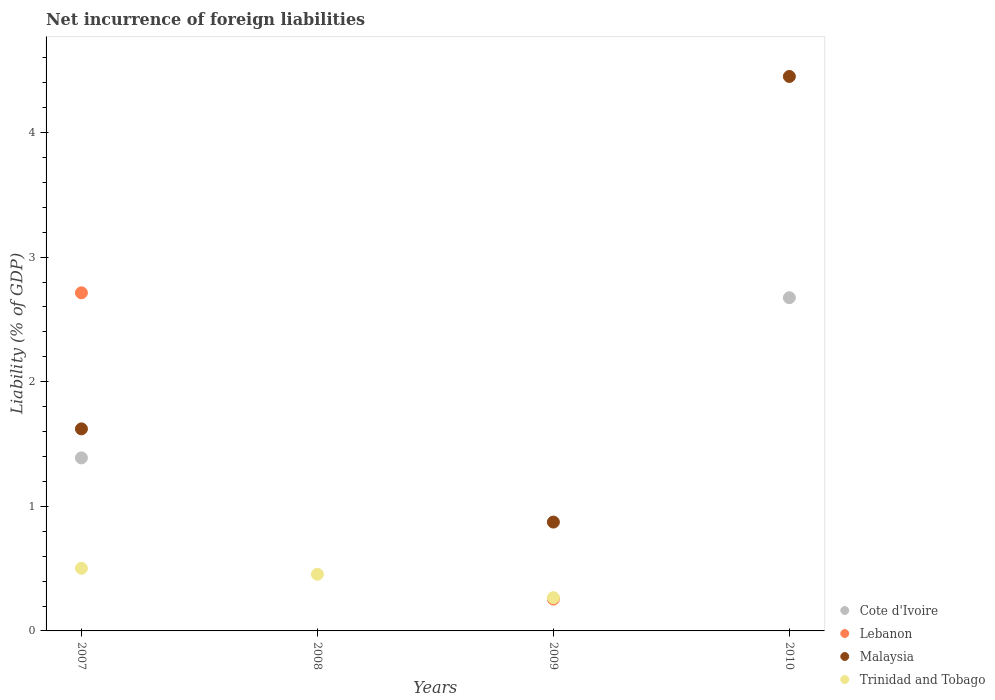How many different coloured dotlines are there?
Keep it short and to the point. 4. What is the net incurrence of foreign liabilities in Malaysia in 2008?
Offer a very short reply. 0. Across all years, what is the maximum net incurrence of foreign liabilities in Lebanon?
Offer a very short reply. 2.71. Across all years, what is the minimum net incurrence of foreign liabilities in Cote d'Ivoire?
Offer a terse response. 0. In which year was the net incurrence of foreign liabilities in Cote d'Ivoire maximum?
Your response must be concise. 2010. What is the total net incurrence of foreign liabilities in Trinidad and Tobago in the graph?
Your response must be concise. 1.22. What is the difference between the net incurrence of foreign liabilities in Cote d'Ivoire in 2007 and that in 2010?
Make the answer very short. -1.29. What is the difference between the net incurrence of foreign liabilities in Lebanon in 2010 and the net incurrence of foreign liabilities in Trinidad and Tobago in 2007?
Your answer should be compact. -0.5. What is the average net incurrence of foreign liabilities in Lebanon per year?
Provide a succinct answer. 0.74. In the year 2010, what is the difference between the net incurrence of foreign liabilities in Cote d'Ivoire and net incurrence of foreign liabilities in Malaysia?
Provide a short and direct response. -1.78. What is the ratio of the net incurrence of foreign liabilities in Lebanon in 2007 to that in 2009?
Your answer should be very brief. 10.61. Is the net incurrence of foreign liabilities in Trinidad and Tobago in 2007 less than that in 2009?
Provide a short and direct response. No. What is the difference between the highest and the second highest net incurrence of foreign liabilities in Trinidad and Tobago?
Keep it short and to the point. 0.05. What is the difference between the highest and the lowest net incurrence of foreign liabilities in Lebanon?
Your answer should be very brief. 2.71. Is it the case that in every year, the sum of the net incurrence of foreign liabilities in Lebanon and net incurrence of foreign liabilities in Malaysia  is greater than the net incurrence of foreign liabilities in Trinidad and Tobago?
Your answer should be very brief. No. What is the difference between two consecutive major ticks on the Y-axis?
Provide a succinct answer. 1. Does the graph contain grids?
Offer a very short reply. No. How many legend labels are there?
Give a very brief answer. 4. What is the title of the graph?
Make the answer very short. Net incurrence of foreign liabilities. What is the label or title of the X-axis?
Provide a succinct answer. Years. What is the label or title of the Y-axis?
Provide a succinct answer. Liability (% of GDP). What is the Liability (% of GDP) in Cote d'Ivoire in 2007?
Keep it short and to the point. 1.39. What is the Liability (% of GDP) in Lebanon in 2007?
Make the answer very short. 2.71. What is the Liability (% of GDP) of Malaysia in 2007?
Provide a succinct answer. 1.62. What is the Liability (% of GDP) of Trinidad and Tobago in 2007?
Give a very brief answer. 0.5. What is the Liability (% of GDP) of Cote d'Ivoire in 2008?
Provide a short and direct response. 0. What is the Liability (% of GDP) of Lebanon in 2008?
Your answer should be compact. 0. What is the Liability (% of GDP) of Trinidad and Tobago in 2008?
Your answer should be compact. 0.45. What is the Liability (% of GDP) in Cote d'Ivoire in 2009?
Give a very brief answer. 0. What is the Liability (% of GDP) of Lebanon in 2009?
Offer a very short reply. 0.26. What is the Liability (% of GDP) of Malaysia in 2009?
Your response must be concise. 0.87. What is the Liability (% of GDP) of Trinidad and Tobago in 2009?
Your response must be concise. 0.27. What is the Liability (% of GDP) of Cote d'Ivoire in 2010?
Offer a terse response. 2.67. What is the Liability (% of GDP) of Malaysia in 2010?
Give a very brief answer. 4.45. What is the Liability (% of GDP) of Trinidad and Tobago in 2010?
Make the answer very short. 0. Across all years, what is the maximum Liability (% of GDP) in Cote d'Ivoire?
Provide a short and direct response. 2.67. Across all years, what is the maximum Liability (% of GDP) of Lebanon?
Provide a succinct answer. 2.71. Across all years, what is the maximum Liability (% of GDP) of Malaysia?
Your response must be concise. 4.45. Across all years, what is the maximum Liability (% of GDP) in Trinidad and Tobago?
Your response must be concise. 0.5. Across all years, what is the minimum Liability (% of GDP) in Cote d'Ivoire?
Your answer should be very brief. 0. Across all years, what is the minimum Liability (% of GDP) of Trinidad and Tobago?
Your answer should be very brief. 0. What is the total Liability (% of GDP) in Cote d'Ivoire in the graph?
Offer a very short reply. 4.06. What is the total Liability (% of GDP) in Lebanon in the graph?
Keep it short and to the point. 2.97. What is the total Liability (% of GDP) of Malaysia in the graph?
Ensure brevity in your answer.  6.94. What is the total Liability (% of GDP) in Trinidad and Tobago in the graph?
Your response must be concise. 1.22. What is the difference between the Liability (% of GDP) in Trinidad and Tobago in 2007 and that in 2008?
Provide a short and direct response. 0.05. What is the difference between the Liability (% of GDP) of Lebanon in 2007 and that in 2009?
Ensure brevity in your answer.  2.46. What is the difference between the Liability (% of GDP) in Malaysia in 2007 and that in 2009?
Keep it short and to the point. 0.75. What is the difference between the Liability (% of GDP) in Trinidad and Tobago in 2007 and that in 2009?
Offer a terse response. 0.24. What is the difference between the Liability (% of GDP) in Cote d'Ivoire in 2007 and that in 2010?
Keep it short and to the point. -1.29. What is the difference between the Liability (% of GDP) in Malaysia in 2007 and that in 2010?
Your answer should be very brief. -2.83. What is the difference between the Liability (% of GDP) in Trinidad and Tobago in 2008 and that in 2009?
Give a very brief answer. 0.19. What is the difference between the Liability (% of GDP) in Malaysia in 2009 and that in 2010?
Offer a terse response. -3.58. What is the difference between the Liability (% of GDP) in Cote d'Ivoire in 2007 and the Liability (% of GDP) in Trinidad and Tobago in 2008?
Keep it short and to the point. 0.93. What is the difference between the Liability (% of GDP) in Lebanon in 2007 and the Liability (% of GDP) in Trinidad and Tobago in 2008?
Keep it short and to the point. 2.26. What is the difference between the Liability (% of GDP) of Malaysia in 2007 and the Liability (% of GDP) of Trinidad and Tobago in 2008?
Your response must be concise. 1.17. What is the difference between the Liability (% of GDP) of Cote d'Ivoire in 2007 and the Liability (% of GDP) of Lebanon in 2009?
Your answer should be very brief. 1.13. What is the difference between the Liability (% of GDP) of Cote d'Ivoire in 2007 and the Liability (% of GDP) of Malaysia in 2009?
Your response must be concise. 0.52. What is the difference between the Liability (% of GDP) of Cote d'Ivoire in 2007 and the Liability (% of GDP) of Trinidad and Tobago in 2009?
Provide a short and direct response. 1.12. What is the difference between the Liability (% of GDP) of Lebanon in 2007 and the Liability (% of GDP) of Malaysia in 2009?
Your answer should be compact. 1.84. What is the difference between the Liability (% of GDP) in Lebanon in 2007 and the Liability (% of GDP) in Trinidad and Tobago in 2009?
Ensure brevity in your answer.  2.45. What is the difference between the Liability (% of GDP) in Malaysia in 2007 and the Liability (% of GDP) in Trinidad and Tobago in 2009?
Your answer should be very brief. 1.35. What is the difference between the Liability (% of GDP) of Cote d'Ivoire in 2007 and the Liability (% of GDP) of Malaysia in 2010?
Offer a very short reply. -3.06. What is the difference between the Liability (% of GDP) of Lebanon in 2007 and the Liability (% of GDP) of Malaysia in 2010?
Offer a terse response. -1.74. What is the difference between the Liability (% of GDP) in Lebanon in 2009 and the Liability (% of GDP) in Malaysia in 2010?
Offer a terse response. -4.19. What is the average Liability (% of GDP) of Cote d'Ivoire per year?
Your response must be concise. 1.02. What is the average Liability (% of GDP) in Lebanon per year?
Keep it short and to the point. 0.74. What is the average Liability (% of GDP) of Malaysia per year?
Keep it short and to the point. 1.74. What is the average Liability (% of GDP) in Trinidad and Tobago per year?
Ensure brevity in your answer.  0.31. In the year 2007, what is the difference between the Liability (% of GDP) in Cote d'Ivoire and Liability (% of GDP) in Lebanon?
Offer a very short reply. -1.32. In the year 2007, what is the difference between the Liability (% of GDP) in Cote d'Ivoire and Liability (% of GDP) in Malaysia?
Ensure brevity in your answer.  -0.23. In the year 2007, what is the difference between the Liability (% of GDP) in Cote d'Ivoire and Liability (% of GDP) in Trinidad and Tobago?
Give a very brief answer. 0.89. In the year 2007, what is the difference between the Liability (% of GDP) of Lebanon and Liability (% of GDP) of Malaysia?
Provide a short and direct response. 1.09. In the year 2007, what is the difference between the Liability (% of GDP) in Lebanon and Liability (% of GDP) in Trinidad and Tobago?
Your answer should be compact. 2.21. In the year 2007, what is the difference between the Liability (% of GDP) in Malaysia and Liability (% of GDP) in Trinidad and Tobago?
Ensure brevity in your answer.  1.12. In the year 2009, what is the difference between the Liability (% of GDP) of Lebanon and Liability (% of GDP) of Malaysia?
Ensure brevity in your answer.  -0.62. In the year 2009, what is the difference between the Liability (% of GDP) in Lebanon and Liability (% of GDP) in Trinidad and Tobago?
Your answer should be very brief. -0.01. In the year 2009, what is the difference between the Liability (% of GDP) in Malaysia and Liability (% of GDP) in Trinidad and Tobago?
Keep it short and to the point. 0.61. In the year 2010, what is the difference between the Liability (% of GDP) of Cote d'Ivoire and Liability (% of GDP) of Malaysia?
Make the answer very short. -1.78. What is the ratio of the Liability (% of GDP) of Trinidad and Tobago in 2007 to that in 2008?
Make the answer very short. 1.11. What is the ratio of the Liability (% of GDP) of Lebanon in 2007 to that in 2009?
Your response must be concise. 10.61. What is the ratio of the Liability (% of GDP) in Malaysia in 2007 to that in 2009?
Your answer should be very brief. 1.86. What is the ratio of the Liability (% of GDP) in Trinidad and Tobago in 2007 to that in 2009?
Offer a terse response. 1.89. What is the ratio of the Liability (% of GDP) of Cote d'Ivoire in 2007 to that in 2010?
Your answer should be compact. 0.52. What is the ratio of the Liability (% of GDP) of Malaysia in 2007 to that in 2010?
Keep it short and to the point. 0.36. What is the ratio of the Liability (% of GDP) of Trinidad and Tobago in 2008 to that in 2009?
Keep it short and to the point. 1.71. What is the ratio of the Liability (% of GDP) in Malaysia in 2009 to that in 2010?
Make the answer very short. 0.2. What is the difference between the highest and the second highest Liability (% of GDP) in Malaysia?
Offer a very short reply. 2.83. What is the difference between the highest and the second highest Liability (% of GDP) in Trinidad and Tobago?
Offer a very short reply. 0.05. What is the difference between the highest and the lowest Liability (% of GDP) of Cote d'Ivoire?
Offer a very short reply. 2.67. What is the difference between the highest and the lowest Liability (% of GDP) of Lebanon?
Your answer should be very brief. 2.71. What is the difference between the highest and the lowest Liability (% of GDP) of Malaysia?
Provide a succinct answer. 4.45. What is the difference between the highest and the lowest Liability (% of GDP) in Trinidad and Tobago?
Offer a very short reply. 0.5. 